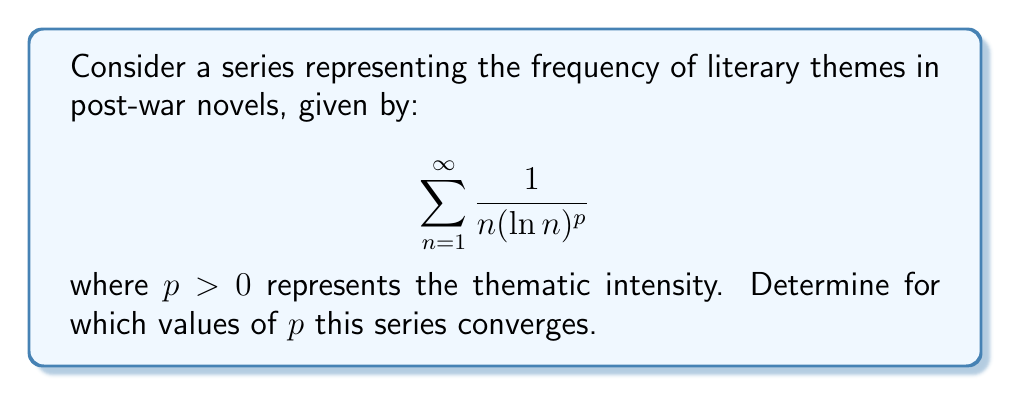Could you help me with this problem? To analyze the convergence of this series, we'll use the integral test. Let's define:

$$f(x) = \frac{1}{x(\ln x)^p}, \quad x \geq 2$$

1) First, we need to verify that $f(x)$ is continuous, positive, and decreasing for $x \geq 2$:
   - $f(x)$ is continuous for $x \geq 2$
   - $f(x) > 0$ for $x \geq 2$
   - $f'(x) = -\frac{1}{x^2(\ln x)^p} - \frac{p}{x^2(\ln x)^{p+1}} < 0$ for $x \geq 2$, so $f(x)$ is decreasing

2) Now we can apply the integral test. The series converges if and only if the following improper integral converges:

   $$\int_2^{\infty} \frac{1}{x(\ln x)^p} dx$$

3) Let's evaluate this integral:
   
   $$\int \frac{1}{x(\ln x)^p} dx = -\frac{1}{(p-1)(\ln x)^{p-1}} + C, \quad \text{for } p \neq 1$$

4) Now, let's evaluate the limits:

   $$\lim_{b\to\infty} \left[-\frac{1}{(p-1)(\ln b)^{p-1}} + \frac{1}{(p-1)(\ln 2)^{p-1}}\right]$$

5) For $p > 1$, this limit is finite:

   $$\lim_{b\to\infty} \left[-\frac{1}{(p-1)(\ln b)^{p-1}} + \frac{1}{(p-1)(\ln 2)^{p-1}}\right] = \frac{1}{(p-1)(\ln 2)^{p-1}}$$

6) For $0 < p \leq 1$, the limit diverges to infinity.

7) For the case $p = 1$, we need to evaluate separately:

   $$\int \frac{1}{x\ln x} dx = \ln(\ln x) + C$$

   $$\lim_{b\to\infty} [\ln(\ln b) - \ln(\ln 2)] = \infty$$

Therefore, the integral (and thus the series) converges for $p > 1$ and diverges for $0 < p \leq 1$.
Answer: The series converges for $p > 1$ and diverges for $0 < p \leq 1$. 